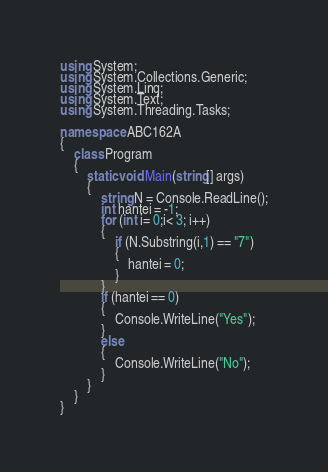Convert code to text. <code><loc_0><loc_0><loc_500><loc_500><_C#_>using System;
using System.Collections.Generic;
using System.Linq;
using System.Text;
using System.Threading.Tasks;

namespace ABC162A
{
    class Program
    {
        static void Main(string[] args)
        {
            string N = Console.ReadLine();
            int hantei = -1;
            for (int i= 0;i< 3; i++)
            {
                if (N.Substring(i,1) == "7")
                {
                    hantei = 0;
                }
            }
            if (hantei == 0)
            {
                Console.WriteLine("Yes");
            }
            else
            {
                Console.WriteLine("No");
            }
        }
    }
}
</code> 